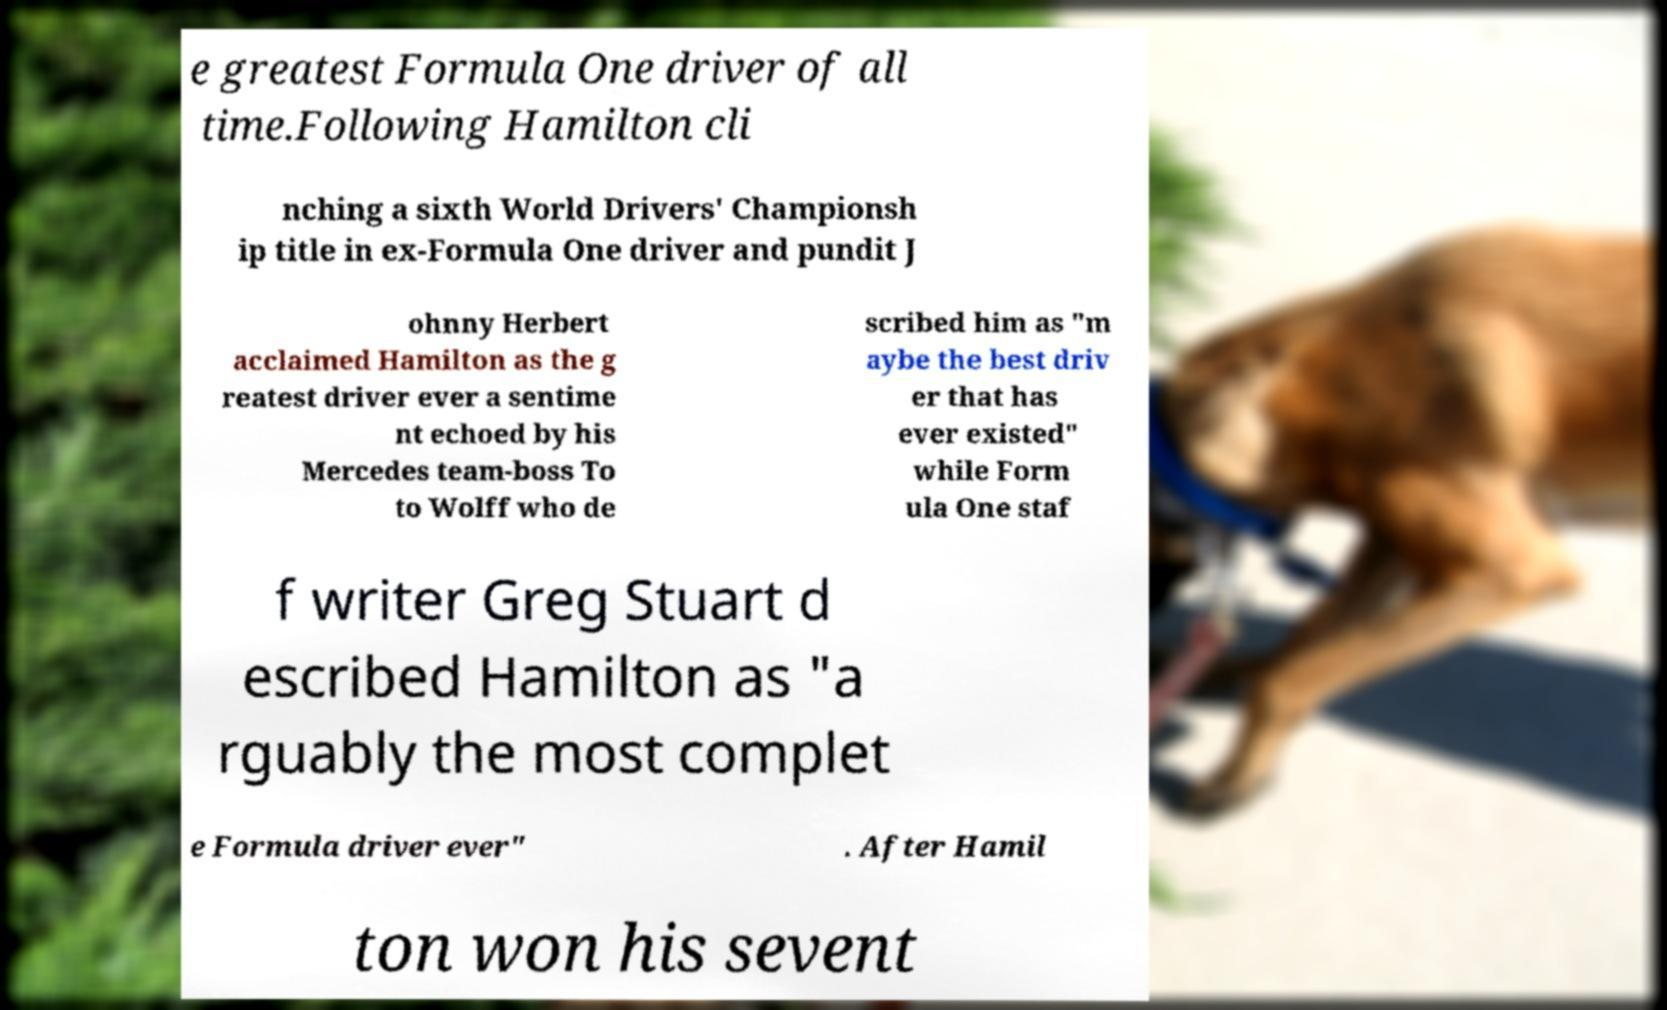I need the written content from this picture converted into text. Can you do that? e greatest Formula One driver of all time.Following Hamilton cli nching a sixth World Drivers' Championsh ip title in ex-Formula One driver and pundit J ohnny Herbert acclaimed Hamilton as the g reatest driver ever a sentime nt echoed by his Mercedes team-boss To to Wolff who de scribed him as "m aybe the best driv er that has ever existed" while Form ula One staf f writer Greg Stuart d escribed Hamilton as "a rguably the most complet e Formula driver ever" . After Hamil ton won his sevent 